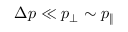<formula> <loc_0><loc_0><loc_500><loc_500>\Delta p \ll p _ { \perp } \sim p _ { \| }</formula> 